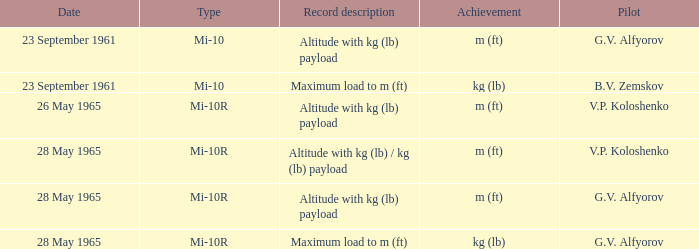Date of 23 september 1961, and a Pilot of b.v. zemskov had what record description? Maximum load to m (ft). 